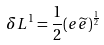<formula> <loc_0><loc_0><loc_500><loc_500>\delta L ^ { 1 } = \frac { 1 } { 2 } ( e \widetilde { e } ) ^ { \frac { 1 } { 2 } }</formula> 